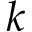Convert formula to latex. <formula><loc_0><loc_0><loc_500><loc_500>k</formula> 